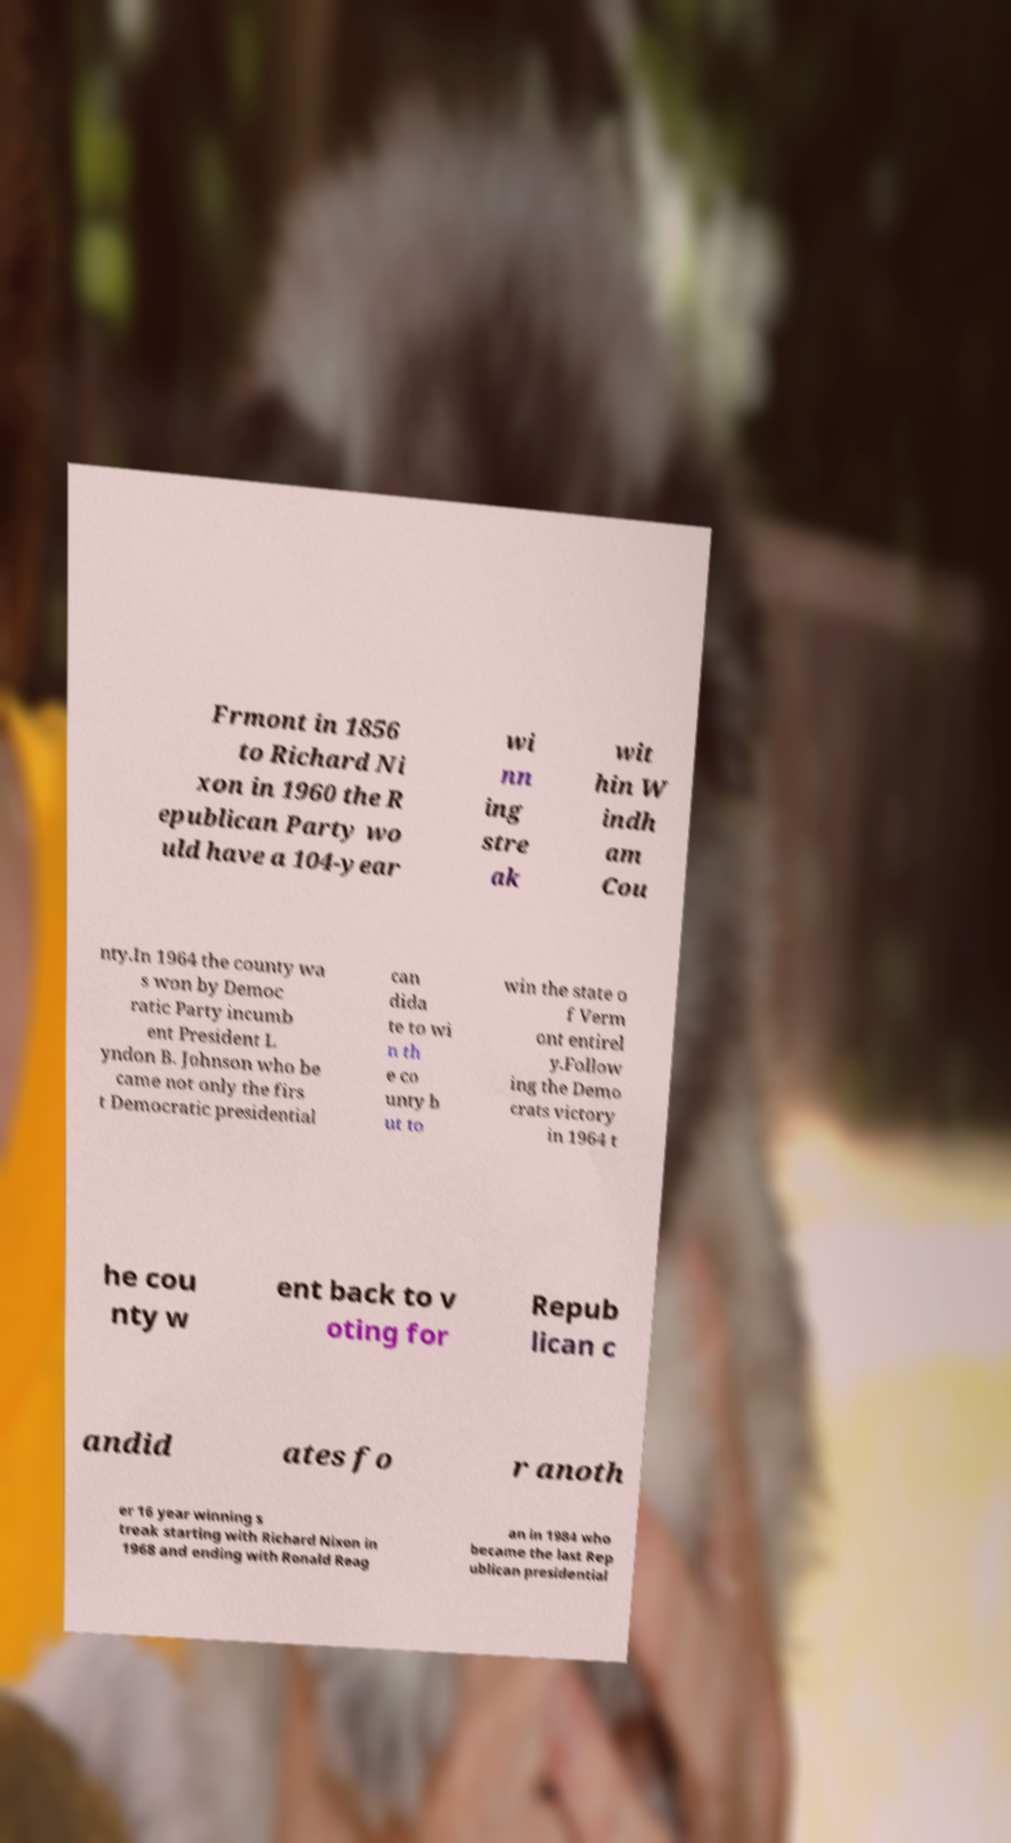Please read and relay the text visible in this image. What does it say? Frmont in 1856 to Richard Ni xon in 1960 the R epublican Party wo uld have a 104-year wi nn ing stre ak wit hin W indh am Cou nty.In 1964 the county wa s won by Democ ratic Party incumb ent President L yndon B. Johnson who be came not only the firs t Democratic presidential can dida te to wi n th e co unty b ut to win the state o f Verm ont entirel y.Follow ing the Demo crats victory in 1964 t he cou nty w ent back to v oting for Repub lican c andid ates fo r anoth er 16 year winning s treak starting with Richard Nixon in 1968 and ending with Ronald Reag an in 1984 who became the last Rep ublican presidential 